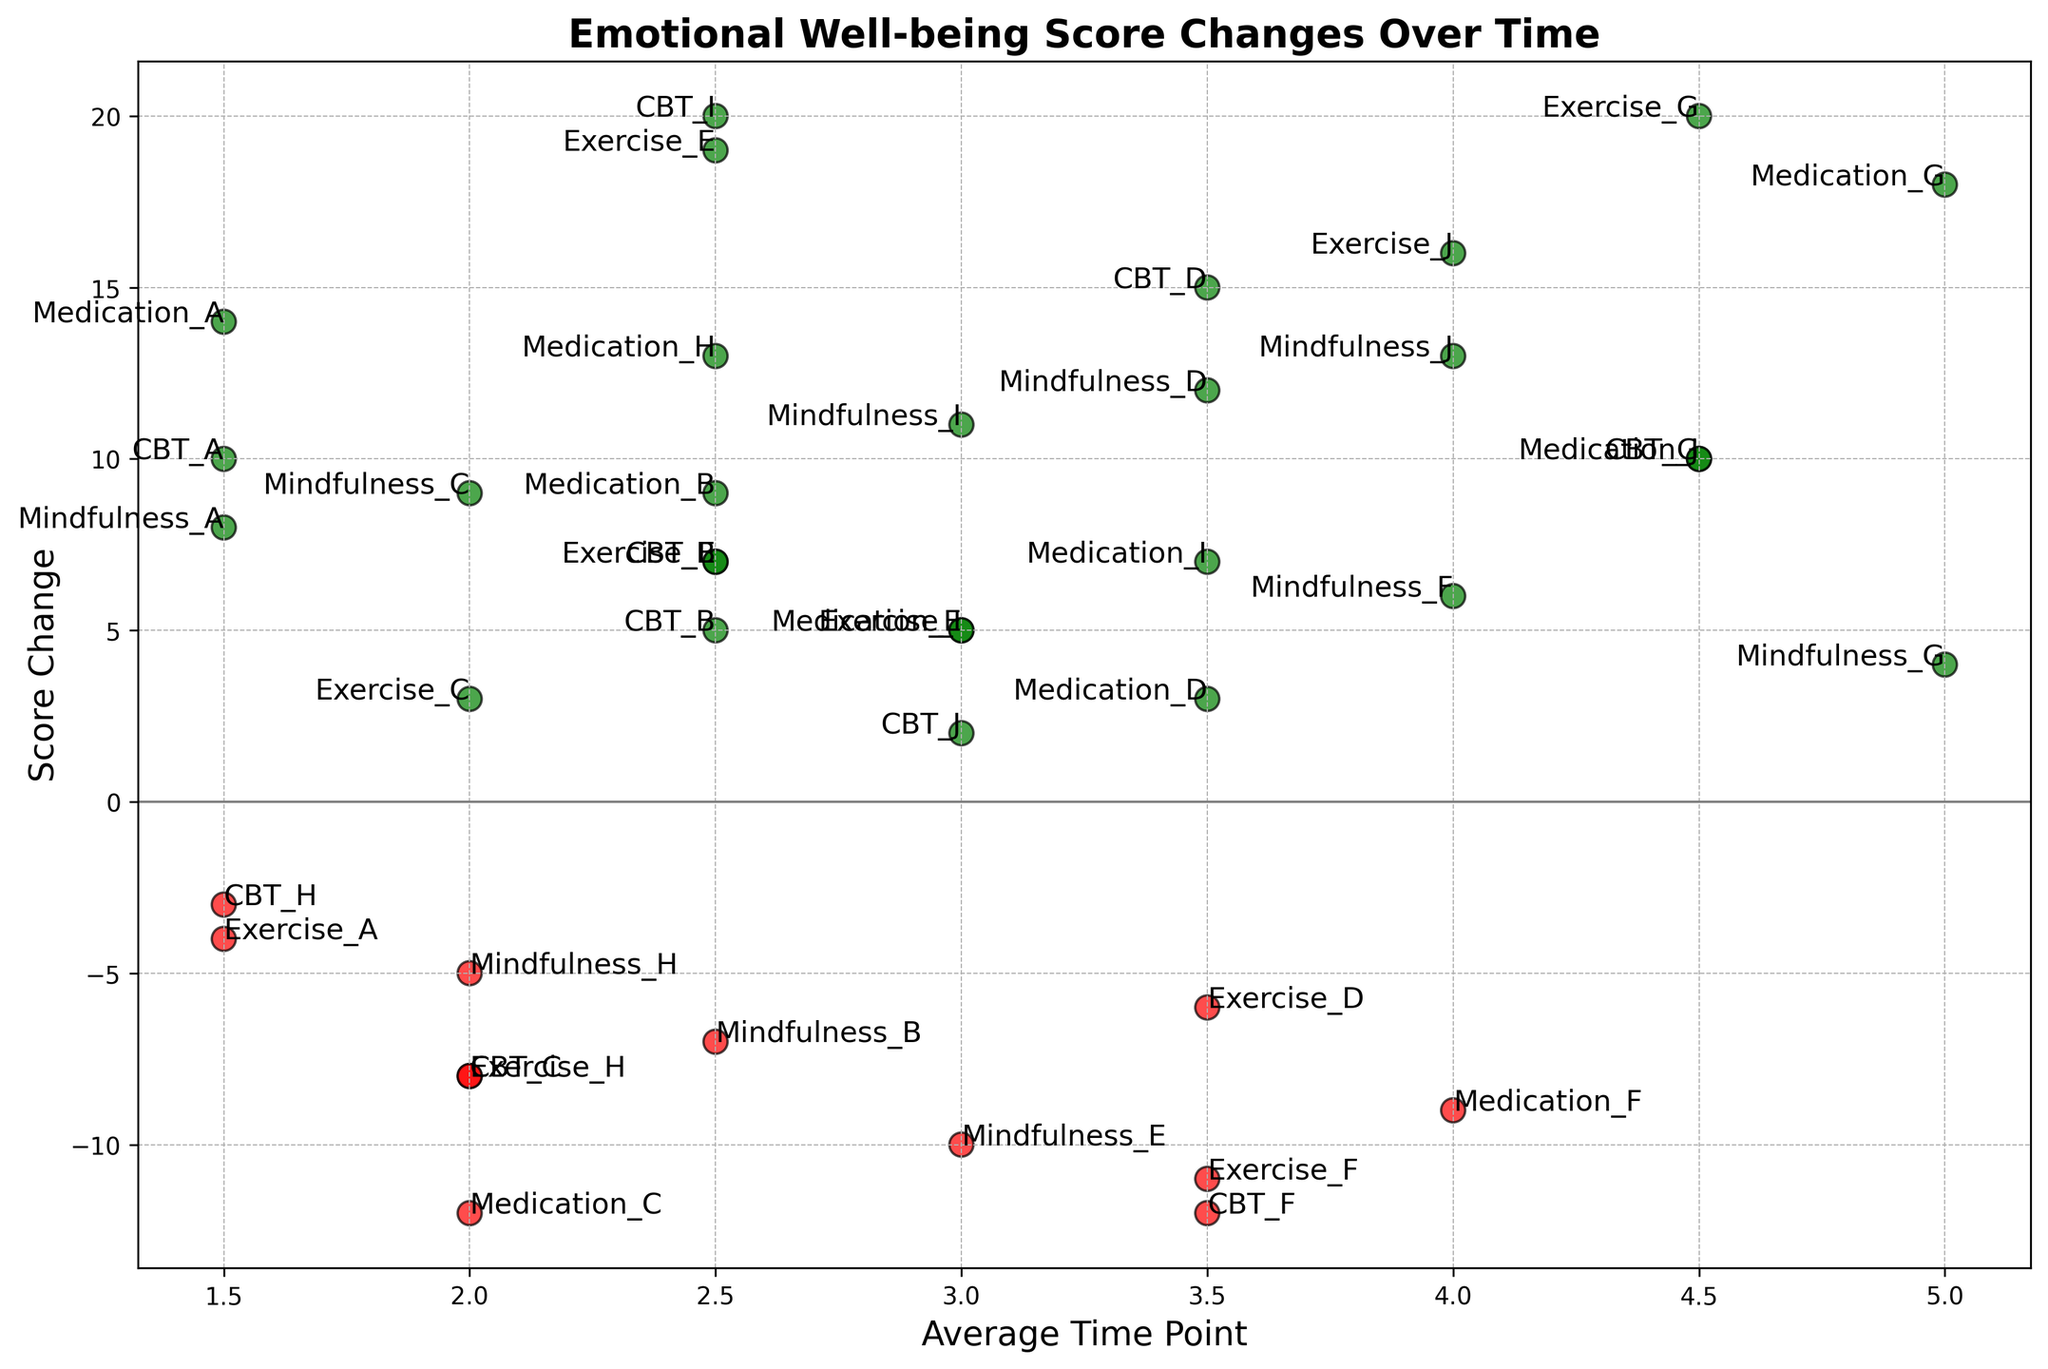What intervention method showed the largest positive score change? To find the largest positive score change, look for the highest green dot on the vertical axis (Score Change). The highest green dot corresponds to 'Exercise_G' with a score change of 20.
Answer: Exercise_G Which intervention had the most negative score change? The most negative score change is represented by the lowest red dot on the vertical axis (Score Change). This dot corresponds to 'CBT_F' with a score change of -12.
Answer: CBT_F What is the average score change for 'CBT' methods? Calculate the sum of score changes for all 'CBT' interventions, then divide by the number of 'CBT' interventions. Summing up (10 + 5 - 8 + 15 + 7 - 12 + 10 - 3 + 20 + 2) gives 46; there are 10 interventions, so 46/10 = 4.6.
Answer: 4.6 Among the 'Mindfulness' interventions, which one had the highest positive score change? Look at the 'Mindfulness' interventions and identify the highest green dot vertically. The highest green dot under 'Mindfulness' corresponds to 'Mindfulness_J' with a score change of 13.
Answer: Mindfulness_J Which intervention had the smallest positive score change? The smallest positive score change is represented by the smallest green dot just above the zero line on the vertical axis. This dot corresponds to 'CBT_J' with a score change of 2.
Answer: CBT_J How many interventions had a negative score change? Count the number of red dots on the scatter plot. There are seven red dots (CBT_C, CBT_F, CBT_H, Mindfulness_B, Mindfulness_E, Mindfulness_H, Exercise_A).
Answer: 7 What is the score change for 'Medication_A'? Locate 'Medication_A' on the plot and read its corresponding score change. 'Medication_A' has a green dot at the level 14 on the vertical axis.
Answer: 14 For which average time point range are the majority of negative score changes clustered? Observe the horizontal axis and check where most red dots are located. Most red dots are clustered around the average time point range of 2 to 3.
Answer: 2 to 3 What's the range of time points for the intervention that had a score change of 13 under 'Medication'? Find the dot for 'Medication_H', whose score change is 13, and check its horizontal placement. 'Medication_H' has time points from 1 to 4.
Answer: 1 to 4 Which intervention method generally shows higher average score changes, 'Exercise' or 'Medication'? Compare the overall position of green dots for 'Exercise' and 'Medication' interventions. 'Exercise' has higher average positive score changes (especially with values 19 and 20), while 'Medication' values are generally lower but still positive.
Answer: Exercise 